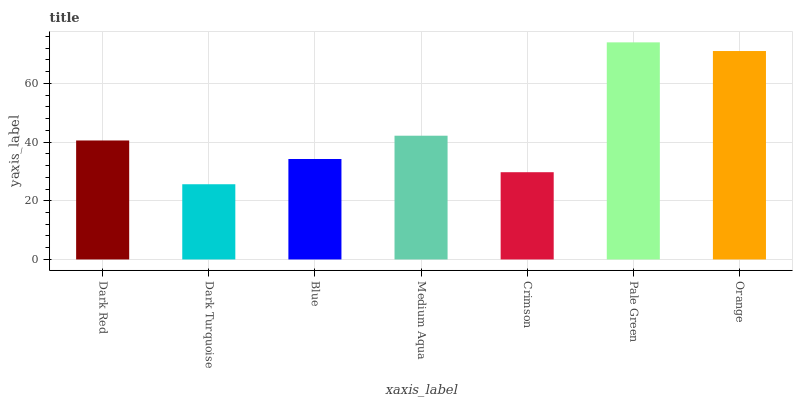Is Dark Turquoise the minimum?
Answer yes or no. Yes. Is Pale Green the maximum?
Answer yes or no. Yes. Is Blue the minimum?
Answer yes or no. No. Is Blue the maximum?
Answer yes or no. No. Is Blue greater than Dark Turquoise?
Answer yes or no. Yes. Is Dark Turquoise less than Blue?
Answer yes or no. Yes. Is Dark Turquoise greater than Blue?
Answer yes or no. No. Is Blue less than Dark Turquoise?
Answer yes or no. No. Is Dark Red the high median?
Answer yes or no. Yes. Is Dark Red the low median?
Answer yes or no. Yes. Is Pale Green the high median?
Answer yes or no. No. Is Pale Green the low median?
Answer yes or no. No. 